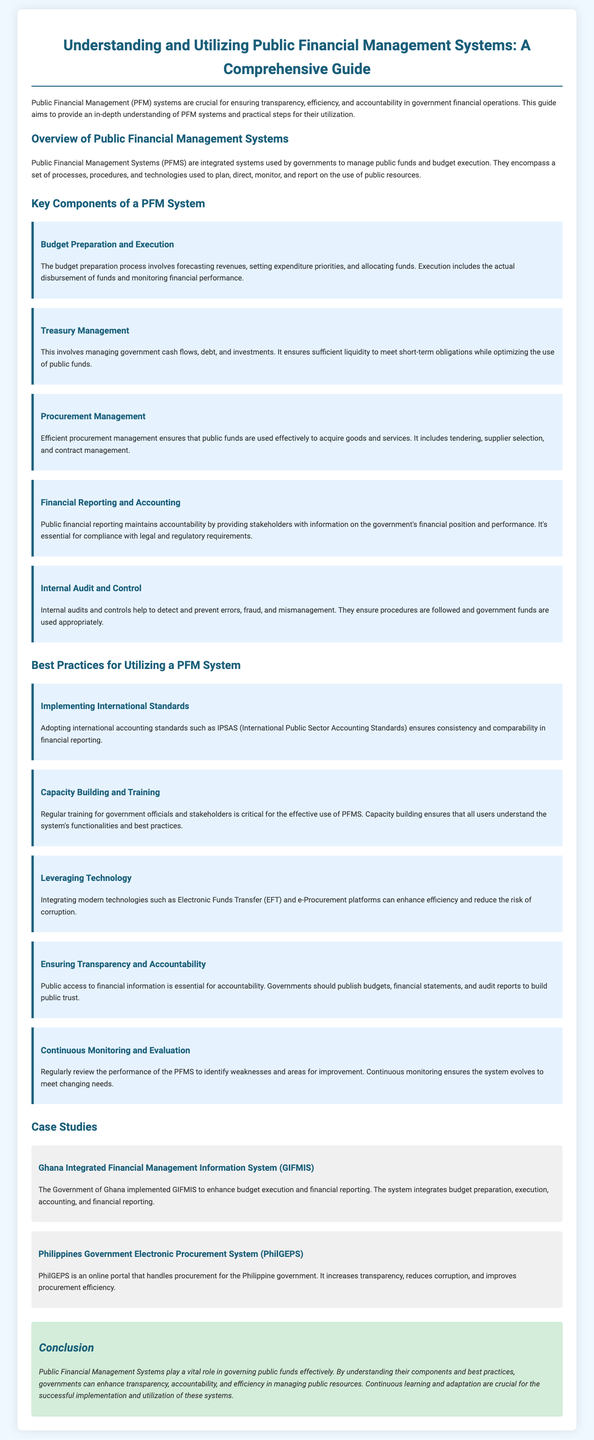What are the key components of a PFM system? The document lists specific components such as Budget Preparation and Execution, Treasury Management, Procurement Management, Financial Reporting and Accounting, and Internal Audit and Control.
Answer: Budget Preparation and Execution, Treasury Management, Procurement Management, Financial Reporting and Accounting, Internal Audit and Control What does PFM stand for? The acronym PFM in the context of the document stands for Public Financial Management.
Answer: Public Financial Management Which international standards are recommended for implementation? The document mentions adopting international accounting standards like IPSAS for consistency and comparability in financial reporting.
Answer: IPSAS What is an example of a case study in the document? The document provides case studies, including the Ghana Integrated Financial Management Information System (GIFMIS) and the Philippines Government Electronic Procurement System (PhilGEPS).
Answer: Ghana Integrated Financial Management Information System (GIFMIS) Why is capacity building important for a PFM system? The document emphasizes that regular training is crucial for government officials and stakeholders to effectively use PFMS and understand its functionalities.
Answer: Training for government officials What does continuous monitoring aim to achieve? Continuous monitoring seeks to identify weaknesses and areas for improvement in the performance of the PFM system over time.
Answer: Identify weaknesses and areas for improvement How does ensuring transparency impact public trust? The document states that public access to financial information builds public trust and is essential for accountability in government financial operations.
Answer: Builds public trust What is one technology mentioned that can enhance efficiency? The document mentions integrating Electronic Funds Transfer (EFT) as a modern technology that can enhance efficiency and reduce the risk of corruption.
Answer: Electronic Funds Transfer (EFT) What does the conclusion of the document emphasize? The conclusion highlights the vital role of PFM systems in effectively governing public funds and stresses the importance of understanding components and best practices.
Answer: The vital role of PFM systems in governing public funds 